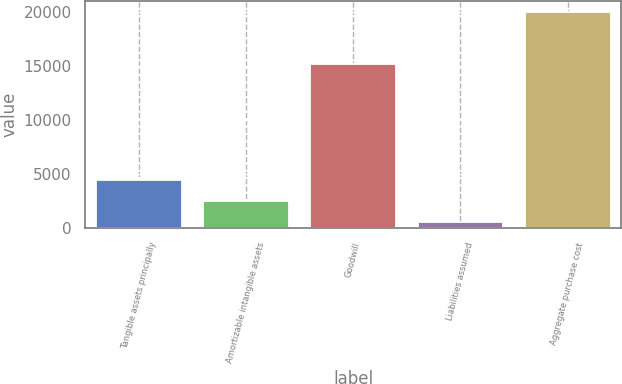Convert chart. <chart><loc_0><loc_0><loc_500><loc_500><bar_chart><fcel>Tangible assets principally<fcel>Amortizable intangible assets<fcel>Goodwill<fcel>Liabilities assumed<fcel>Aggregate purchase cost<nl><fcel>4429.8<fcel>2473.9<fcel>15260<fcel>518<fcel>20077<nl></chart> 